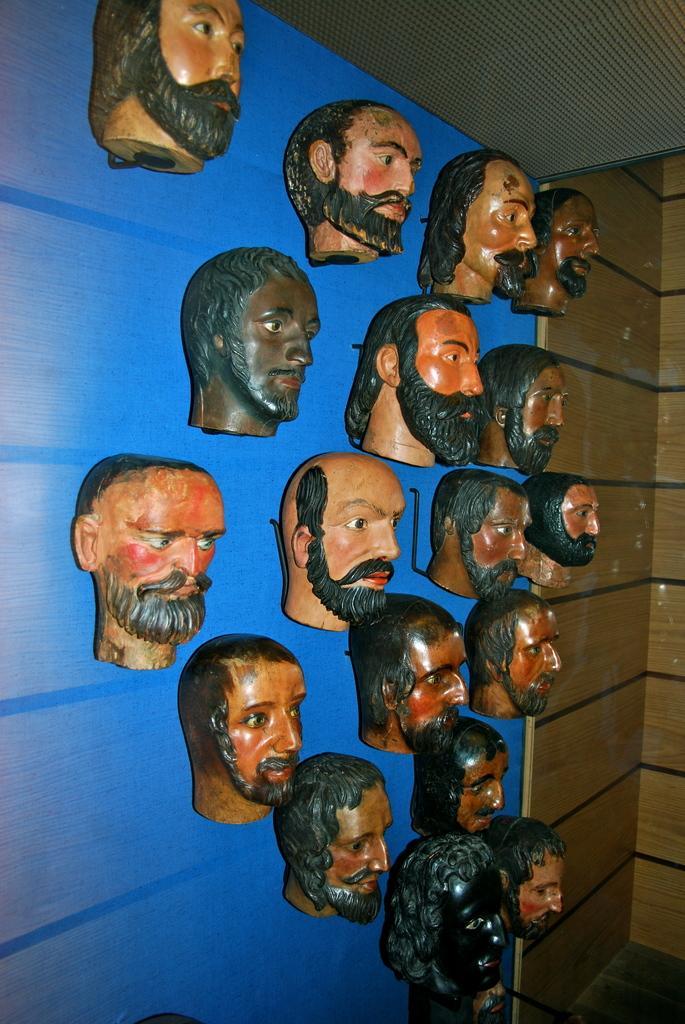Could you give a brief overview of what you see in this image? In this image we can see there are depictions of a person's head are hanging on the wall. 